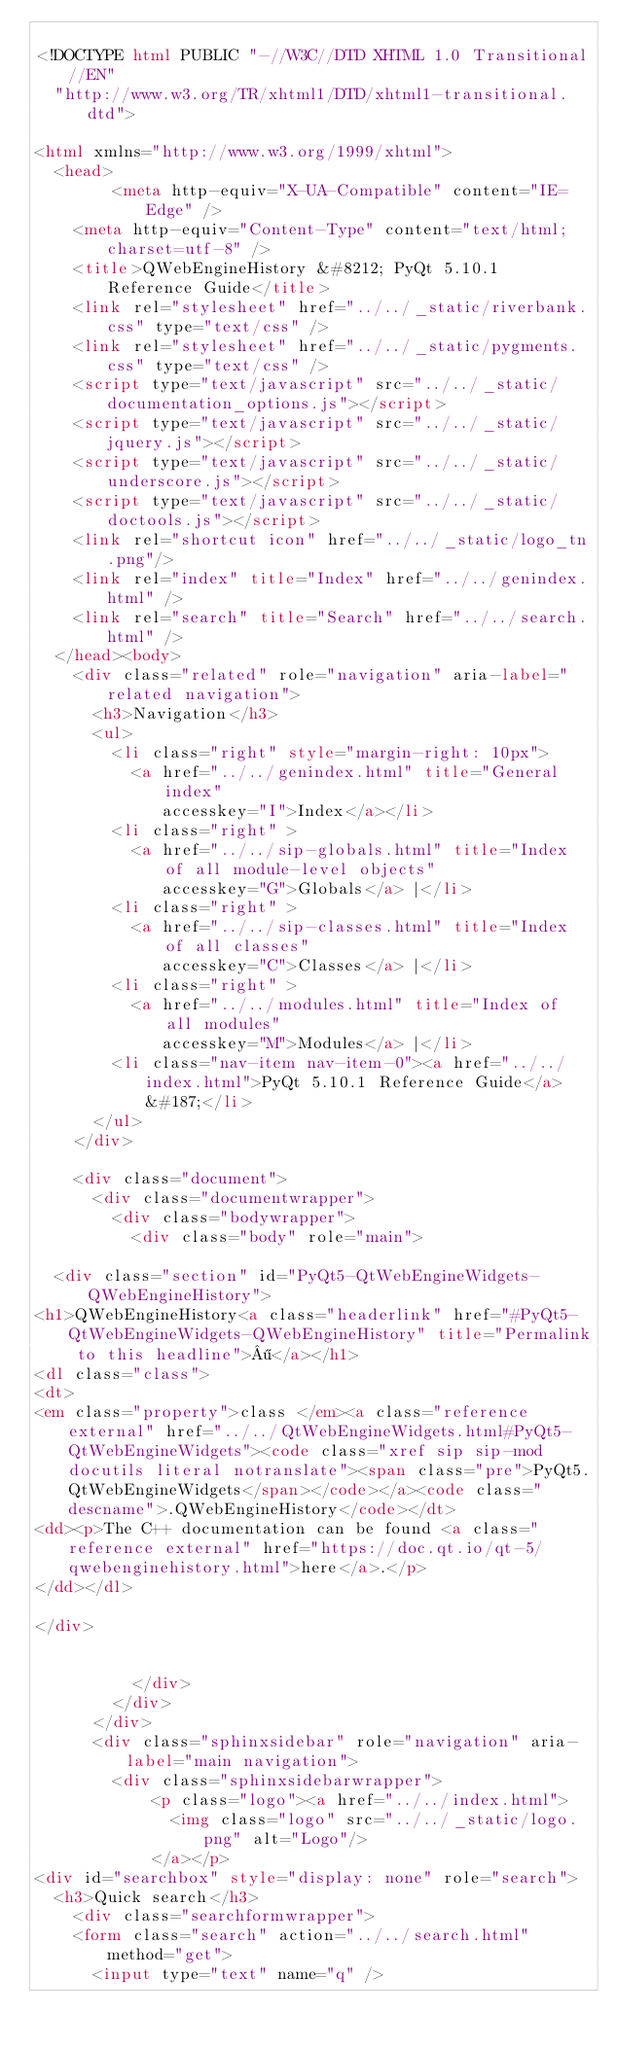Convert code to text. <code><loc_0><loc_0><loc_500><loc_500><_HTML_>
<!DOCTYPE html PUBLIC "-//W3C//DTD XHTML 1.0 Transitional//EN"
  "http://www.w3.org/TR/xhtml1/DTD/xhtml1-transitional.dtd">

<html xmlns="http://www.w3.org/1999/xhtml">
  <head>
        <meta http-equiv="X-UA-Compatible" content="IE=Edge" />
    <meta http-equiv="Content-Type" content="text/html; charset=utf-8" />
    <title>QWebEngineHistory &#8212; PyQt 5.10.1 Reference Guide</title>
    <link rel="stylesheet" href="../../_static/riverbank.css" type="text/css" />
    <link rel="stylesheet" href="../../_static/pygments.css" type="text/css" />
    <script type="text/javascript" src="../../_static/documentation_options.js"></script>
    <script type="text/javascript" src="../../_static/jquery.js"></script>
    <script type="text/javascript" src="../../_static/underscore.js"></script>
    <script type="text/javascript" src="../../_static/doctools.js"></script>
    <link rel="shortcut icon" href="../../_static/logo_tn.png"/>
    <link rel="index" title="Index" href="../../genindex.html" />
    <link rel="search" title="Search" href="../../search.html" /> 
  </head><body>
    <div class="related" role="navigation" aria-label="related navigation">
      <h3>Navigation</h3>
      <ul>
        <li class="right" style="margin-right: 10px">
          <a href="../../genindex.html" title="General index"
             accesskey="I">Index</a></li>
        <li class="right" >
          <a href="../../sip-globals.html" title="Index of all module-level objects"
             accesskey="G">Globals</a> |</li>
        <li class="right" >
          <a href="../../sip-classes.html" title="Index of all classes"
             accesskey="C">Classes</a> |</li>
        <li class="right" >
          <a href="../../modules.html" title="Index of all modules"
             accesskey="M">Modules</a> |</li>
        <li class="nav-item nav-item-0"><a href="../../index.html">PyQt 5.10.1 Reference Guide</a> &#187;</li> 
      </ul>
    </div>  

    <div class="document">
      <div class="documentwrapper">
        <div class="bodywrapper">
          <div class="body" role="main">
            
  <div class="section" id="PyQt5-QtWebEngineWidgets-QWebEngineHistory">
<h1>QWebEngineHistory<a class="headerlink" href="#PyQt5-QtWebEngineWidgets-QWebEngineHistory" title="Permalink to this headline">¶</a></h1>
<dl class="class">
<dt>
<em class="property">class </em><a class="reference external" href="../../QtWebEngineWidgets.html#PyQt5-QtWebEngineWidgets"><code class="xref sip sip-mod docutils literal notranslate"><span class="pre">PyQt5.QtWebEngineWidgets</span></code></a><code class="descname">.QWebEngineHistory</code></dt>
<dd><p>The C++ documentation can be found <a class="reference external" href="https://doc.qt.io/qt-5/qwebenginehistory.html">here</a>.</p>
</dd></dl>

</div>


          </div>
        </div>
      </div>
      <div class="sphinxsidebar" role="navigation" aria-label="main navigation">
        <div class="sphinxsidebarwrapper">
            <p class="logo"><a href="../../index.html">
              <img class="logo" src="../../_static/logo.png" alt="Logo"/>
            </a></p>
<div id="searchbox" style="display: none" role="search">
  <h3>Quick search</h3>
    <div class="searchformwrapper">
    <form class="search" action="../../search.html" method="get">
      <input type="text" name="q" /></code> 